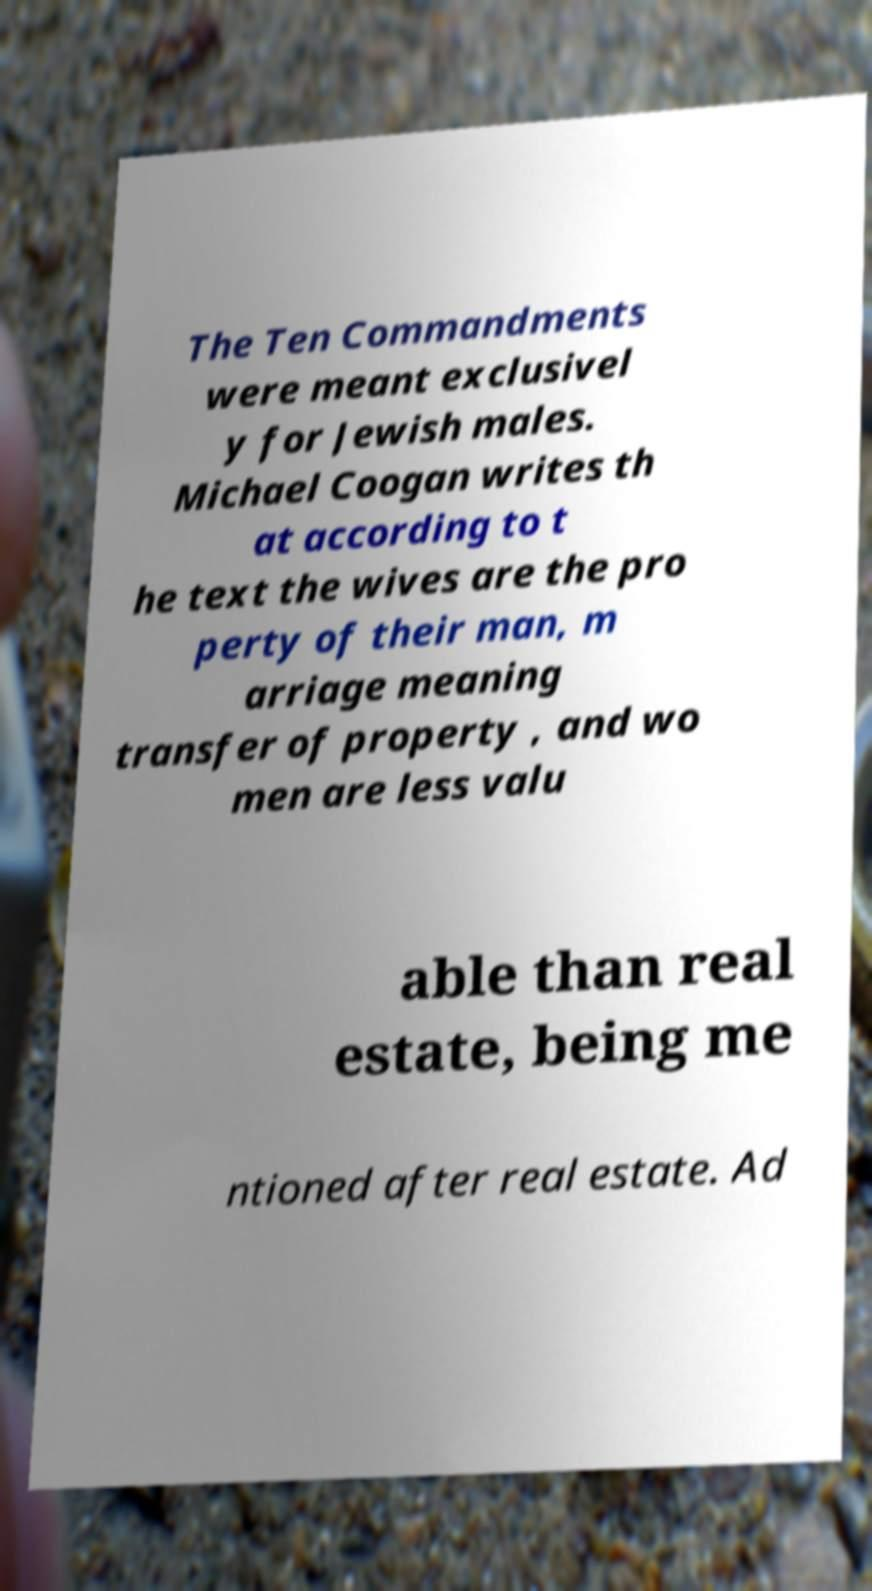For documentation purposes, I need the text within this image transcribed. Could you provide that? The Ten Commandments were meant exclusivel y for Jewish males. Michael Coogan writes th at according to t he text the wives are the pro perty of their man, m arriage meaning transfer of property , and wo men are less valu able than real estate, being me ntioned after real estate. Ad 